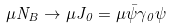<formula> <loc_0><loc_0><loc_500><loc_500>\mu N _ { B } \rightarrow \mu J _ { 0 } = \mu \bar { \psi } \gamma _ { 0 } \psi</formula> 